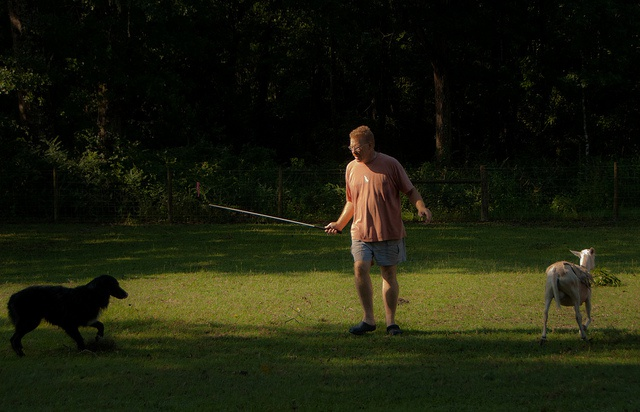Describe the objects in this image and their specific colors. I can see people in black, maroon, tan, and brown tones, dog in black and darkgreen tones, and sheep in black, gray, and darkgreen tones in this image. 